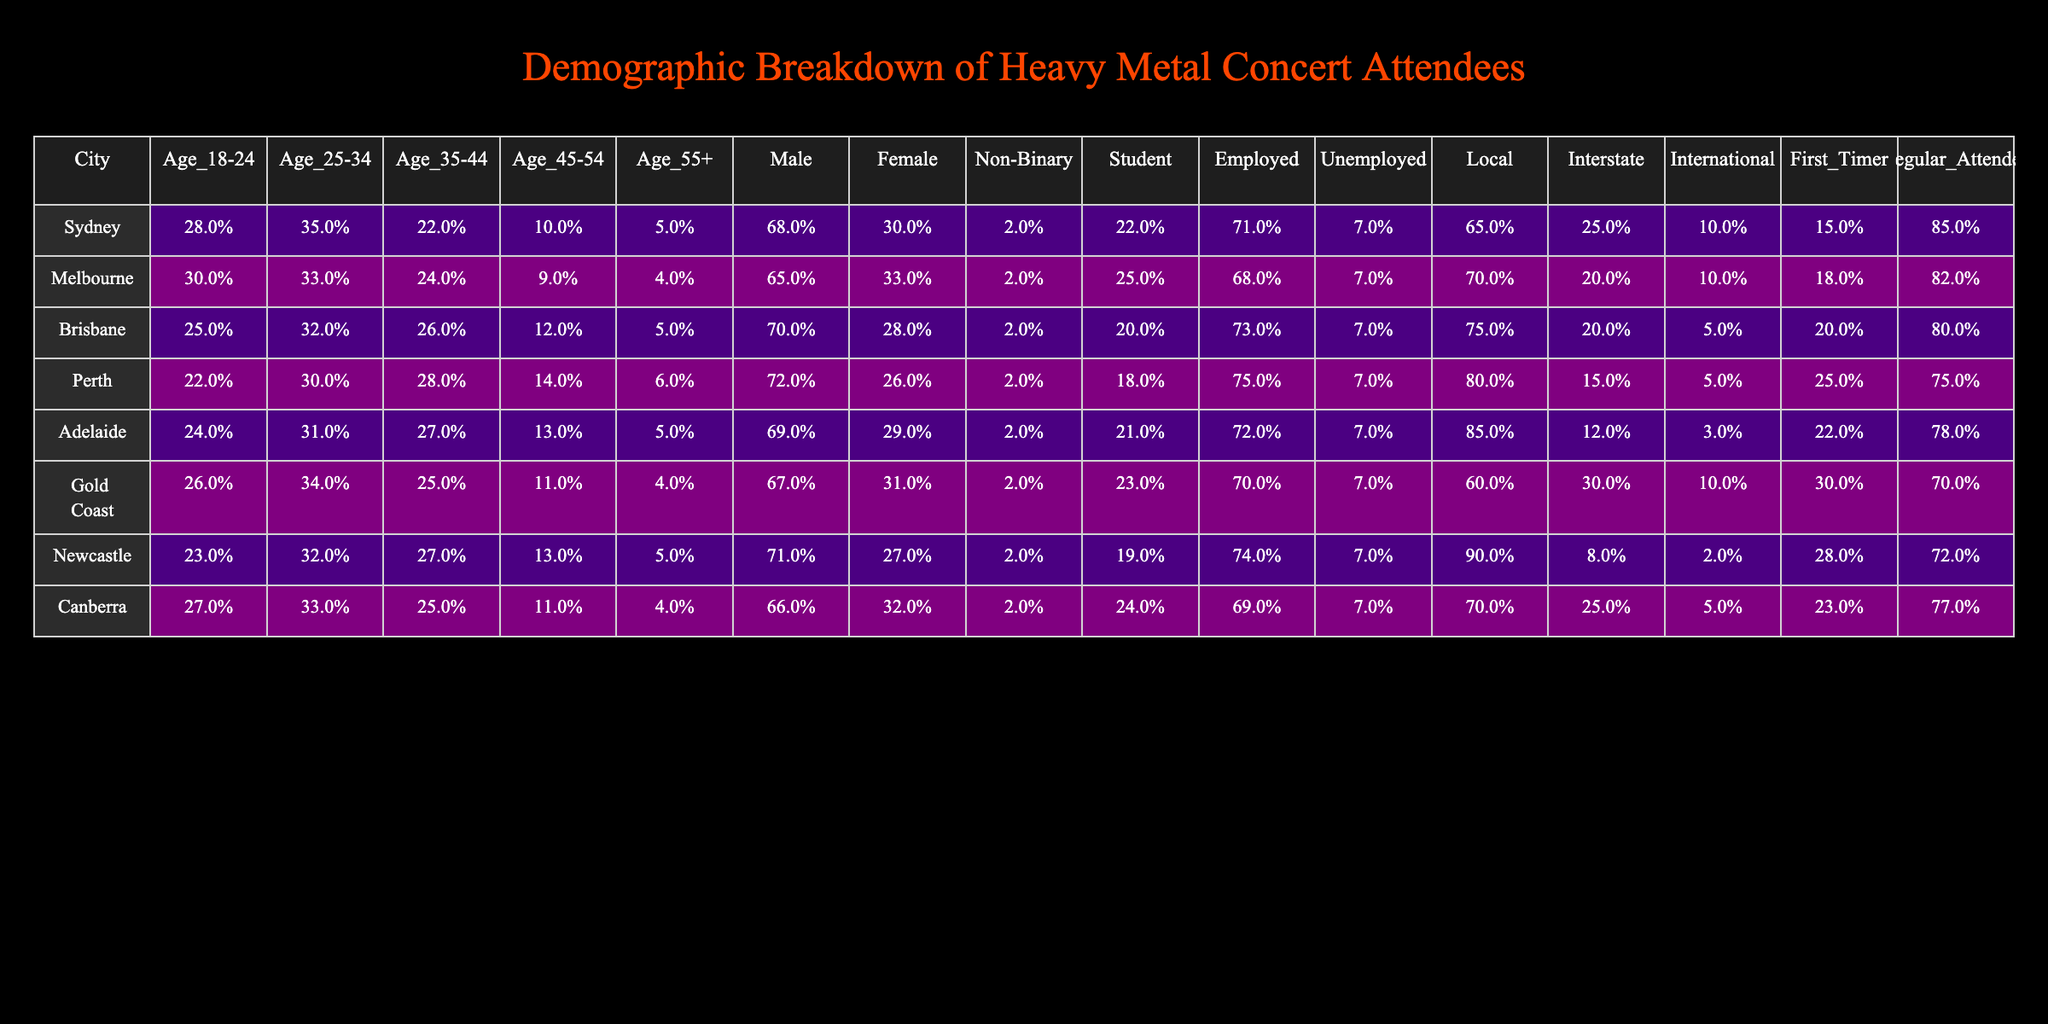What percentage of males attend heavy metal concerts in Brisbane? In the Brisbane row of the table, the percentage of males is listed as 70%.
Answer: 70% Which city has the highest percentage of attendees aged 18-24? By looking at the Age_18-24 column, Sydney has the highest percentage at 28%.
Answer: Sydney What is the total percentage of attendees aged 35-44 and 45-54 in Melbourne? In Melbourne, the age group percentages for 35-44 and 45-54 are 24% and 9%, respectively. Adding these gives 24% + 9% = 33%.
Answer: 33% Are there more male attendees or female attendees in Adelaide? The table shows 69% male attendees and 29% female attendees in Adelaide. Therefore, there are more male attendees.
Answer: Yes What city has the lowest percentage of international attendees? By examining the International column, Newcastle has the lowest percentage at 2%.
Answer: Newcastle What is the percentage difference in the number of unemployed attendees between Perth and Brisbane? Perth has 7% unemployed and Brisbane has 7% as well, so the difference is 7% - 7% = 0%.
Answer: 0% Which city has the highest percentage of first-time attendees? In the First_Timer column, Brisbane has the highest percentage at 20%.
Answer: Brisbane How many local attendees are there in Gold Coast as a percentage? The Gold Coast row lists local attendees at 60%.
Answer: 60% Is the percentage of non-binary attendees consistent across all cities? The Non-Binary column consistently shows 2% across all cities, indicating a consistent percentage.
Answer: Yes In which city do regular attendees constitute the smallest percentage? The Regular_Attendee column shows that Newcastle has the smallest percentage at 72%.
Answer: Newcastle What percentage of attendees aged 55 and over are there in Melbourne? From the table, the percentage of attendees aged 55 and over in Melbourne is 4%.
Answer: 4% If we average the percentage of female attendees across all cities, what do we get? The female percentages for the seven cities are 30%, 33%, 28%, 26%, 29%, 31%, and 27%. Adding these gives 204%, and averaging over 7 cities gives 204% / 7 = approximately 29.14%.
Answer: 29.14% 